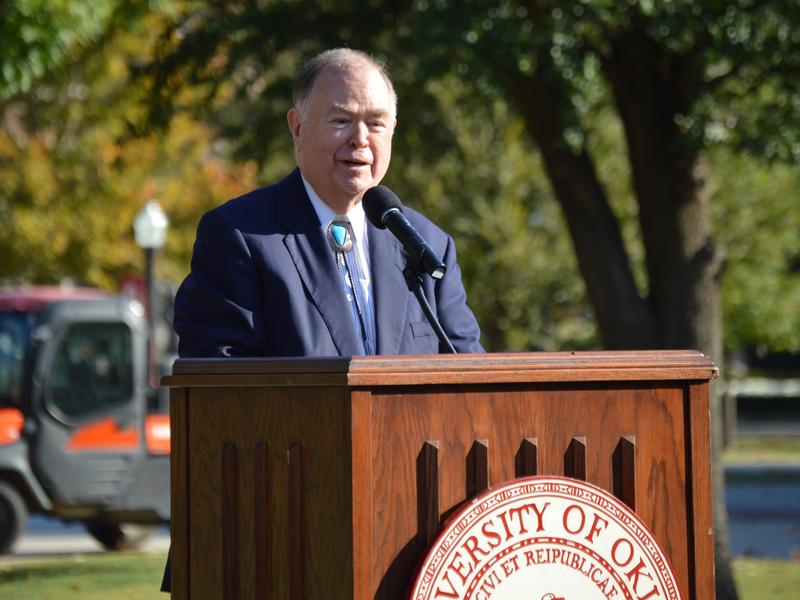What might be the historical or cultural significance of holding such an event at this university? The University of Oklahoma has a rich history and a deep-rooted place in the educational landscape. Hosting significant events at the university not only highlights its historical contributions but also demonstrates its ongoing cultural significance in promoting higher education and research excellence. Such events can be seen as a tribute to the university's lasting impact on education and society at large. How do these events typically impact the student body and faculty? Events like these generally boost morale and foster a sense of community among students and faculty. They provide recognition, celebrate the university's accomplishments, and solidify a collective identity. Additionally, they offer networking opportunities and serve as a platform for students and faculty to engage with broader educational and professional communities. 